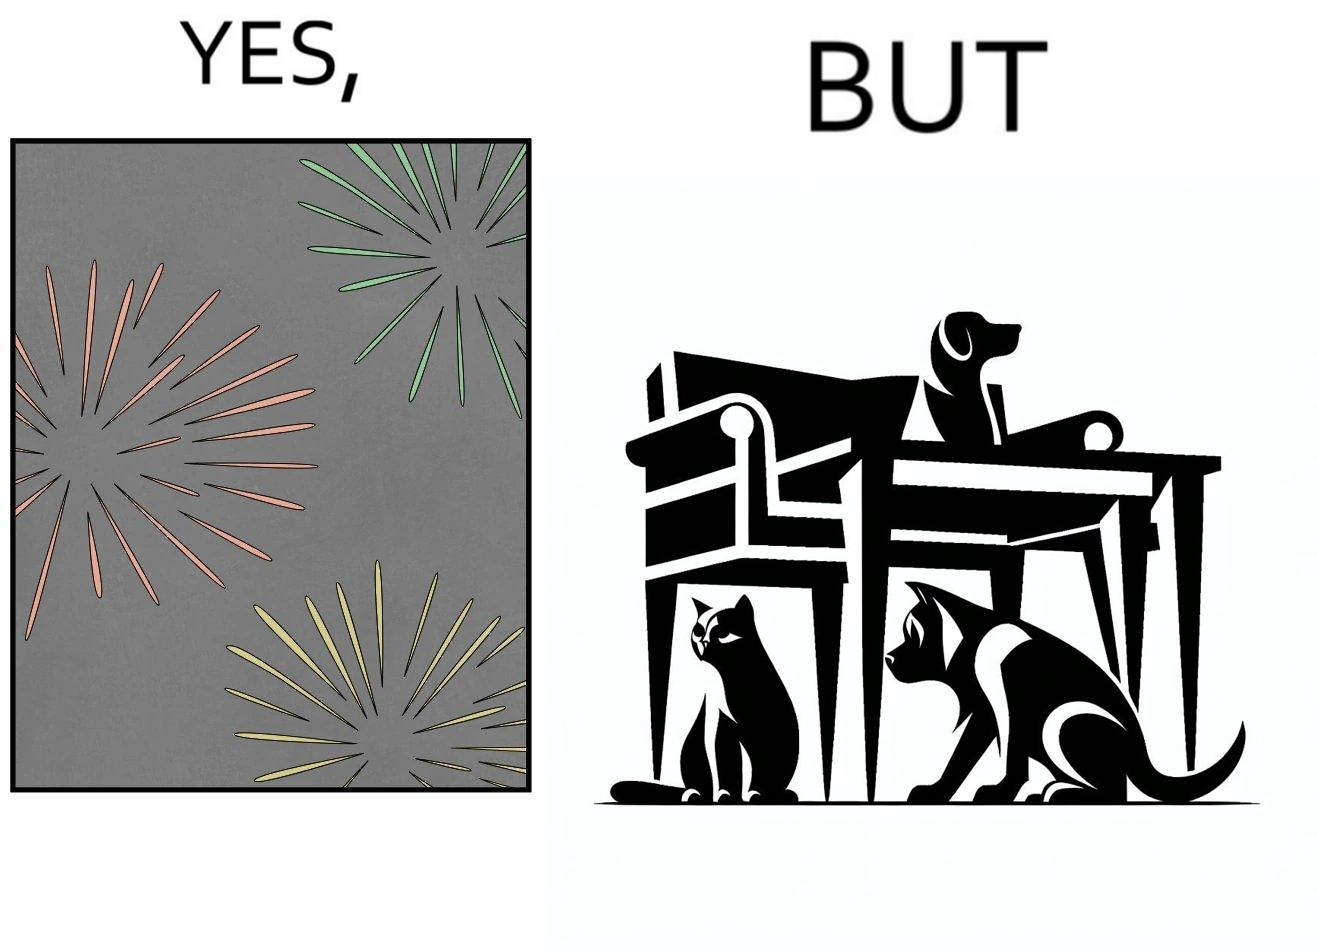Does this image contain satire or humor? Yes, this image is satirical. 